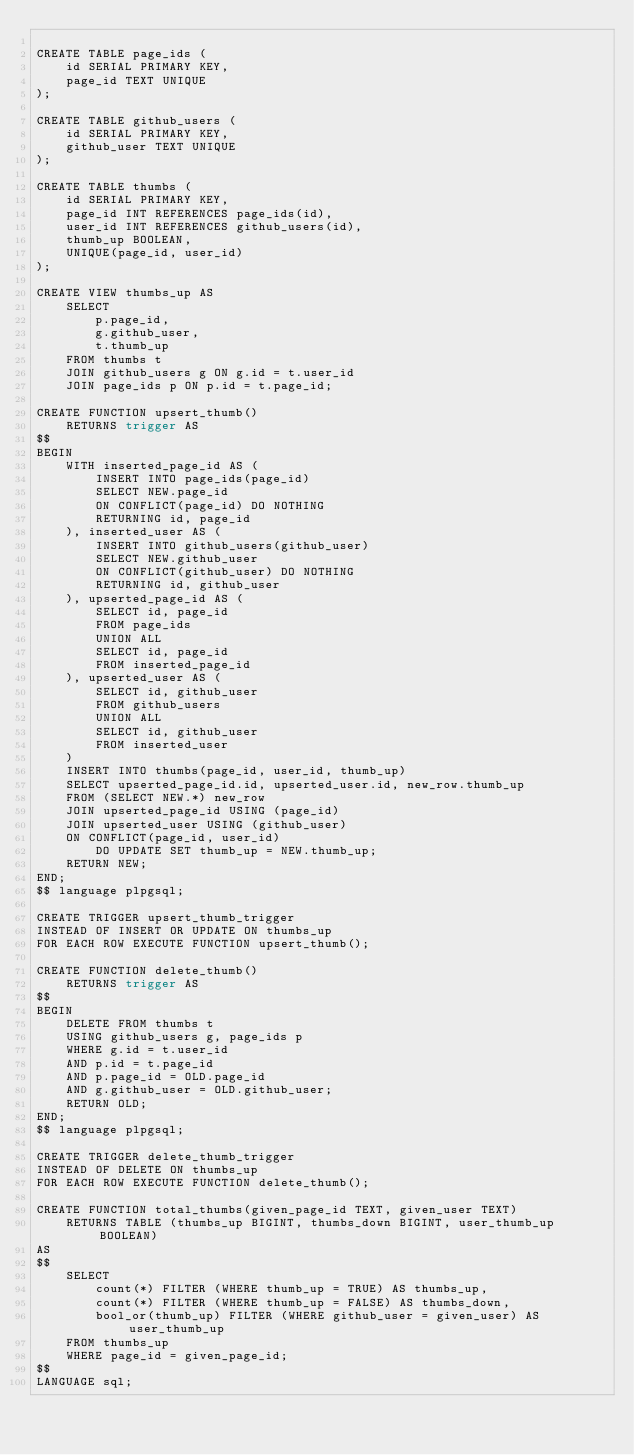<code> <loc_0><loc_0><loc_500><loc_500><_SQL_>
CREATE TABLE page_ids (
    id SERIAL PRIMARY KEY,
    page_id TEXT UNIQUE
);

CREATE TABLE github_users (
    id SERIAL PRIMARY KEY,
    github_user TEXT UNIQUE
);

CREATE TABLE thumbs (
    id SERIAL PRIMARY KEY,
    page_id INT REFERENCES page_ids(id),
    user_id INT REFERENCES github_users(id),
    thumb_up BOOLEAN,
    UNIQUE(page_id, user_id)
);

CREATE VIEW thumbs_up AS
    SELECT
        p.page_id,
        g.github_user,
        t.thumb_up
    FROM thumbs t
    JOIN github_users g ON g.id = t.user_id
    JOIN page_ids p ON p.id = t.page_id;

CREATE FUNCTION upsert_thumb()
    RETURNS trigger AS
$$
BEGIN
    WITH inserted_page_id AS (
        INSERT INTO page_ids(page_id)
        SELECT NEW.page_id
        ON CONFLICT(page_id) DO NOTHING
        RETURNING id, page_id
    ), inserted_user AS (
        INSERT INTO github_users(github_user)
        SELECT NEW.github_user
        ON CONFLICT(github_user) DO NOTHING
        RETURNING id, github_user
    ), upserted_page_id AS (
        SELECT id, page_id
        FROM page_ids
        UNION ALL
        SELECT id, page_id
        FROM inserted_page_id
    ), upserted_user AS (
        SELECT id, github_user
        FROM github_users
        UNION ALL
        SELECT id, github_user
        FROM inserted_user
    )
    INSERT INTO thumbs(page_id, user_id, thumb_up)
    SELECT upserted_page_id.id, upserted_user.id, new_row.thumb_up
    FROM (SELECT NEW.*) new_row
    JOIN upserted_page_id USING (page_id)
    JOIN upserted_user USING (github_user)
    ON CONFLICT(page_id, user_id)
        DO UPDATE SET thumb_up = NEW.thumb_up;
    RETURN NEW;
END;
$$ language plpgsql;

CREATE TRIGGER upsert_thumb_trigger
INSTEAD OF INSERT OR UPDATE ON thumbs_up
FOR EACH ROW EXECUTE FUNCTION upsert_thumb();

CREATE FUNCTION delete_thumb()
    RETURNS trigger AS
$$
BEGIN
    DELETE FROM thumbs t
    USING github_users g, page_ids p
    WHERE g.id = t.user_id
    AND p.id = t.page_id
    AND p.page_id = OLD.page_id
    AND g.github_user = OLD.github_user;
    RETURN OLD;
END;
$$ language plpgsql;

CREATE TRIGGER delete_thumb_trigger
INSTEAD OF DELETE ON thumbs_up
FOR EACH ROW EXECUTE FUNCTION delete_thumb();

CREATE FUNCTION total_thumbs(given_page_id TEXT, given_user TEXT)
    RETURNS TABLE (thumbs_up BIGINT, thumbs_down BIGINT, user_thumb_up BOOLEAN)
AS
$$
    SELECT
        count(*) FILTER (WHERE thumb_up = TRUE) AS thumbs_up,
        count(*) FILTER (WHERE thumb_up = FALSE) AS thumbs_down,
        bool_or(thumb_up) FILTER (WHERE github_user = given_user) AS user_thumb_up
    FROM thumbs_up
    WHERE page_id = given_page_id;
$$
LANGUAGE sql;
</code> 